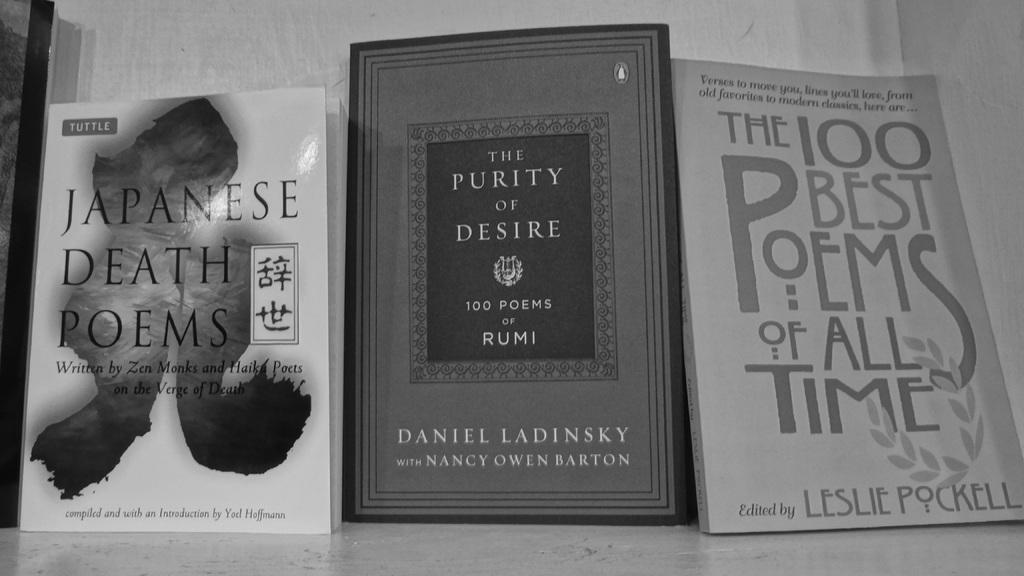Provide a one-sentence caption for the provided image. Three books in black and white with titles like JAPANESE DEATH POEMS. 